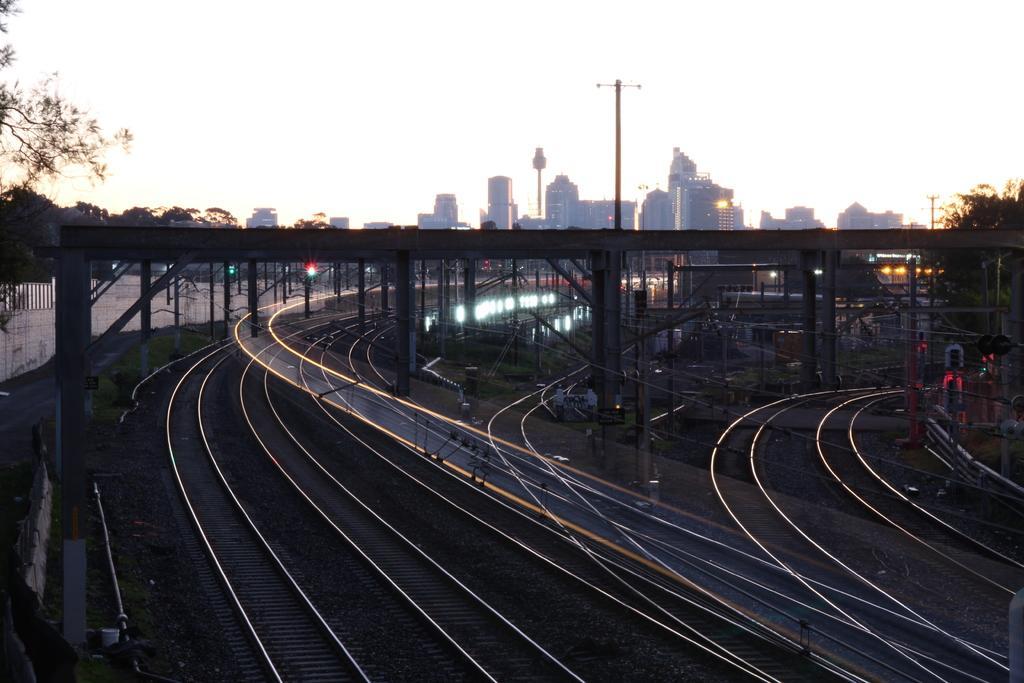In one or two sentences, can you explain what this image depicts? In this image I can see number of railway tracks, number of poles and on the both sides of the image I can see number of trees. In the background I can see number of lights, number of buildings and the sky. 